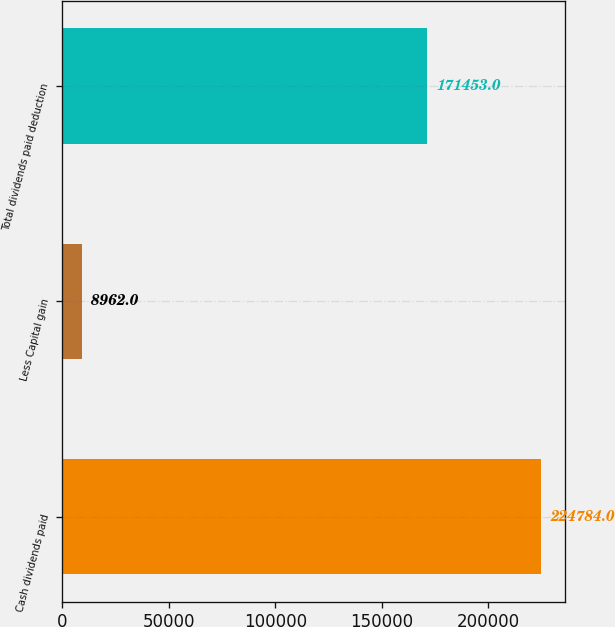<chart> <loc_0><loc_0><loc_500><loc_500><bar_chart><fcel>Cash dividends paid<fcel>Less Capital gain<fcel>Total dividends paid deduction<nl><fcel>224784<fcel>8962<fcel>171453<nl></chart> 